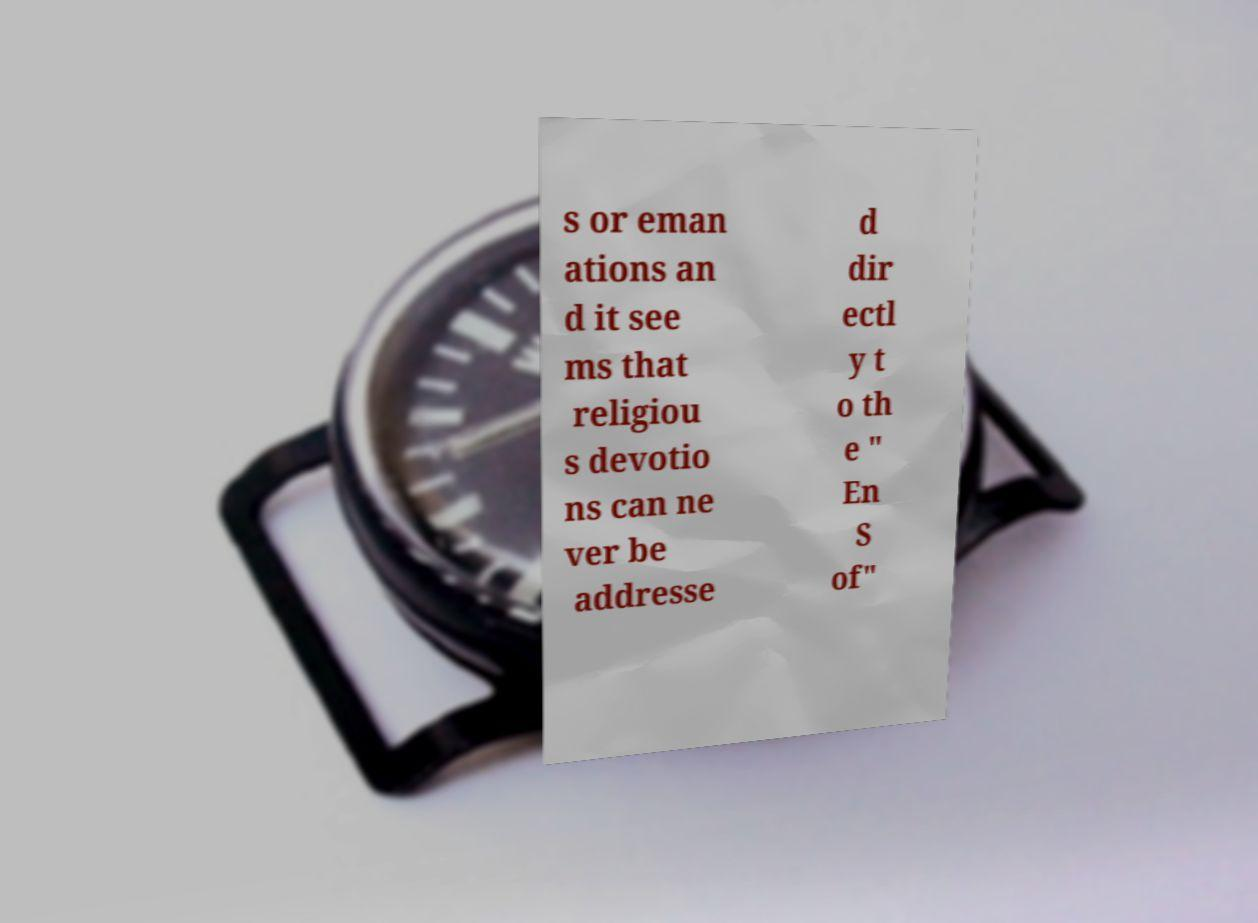Please identify and transcribe the text found in this image. s or eman ations an d it see ms that religiou s devotio ns can ne ver be addresse d dir ectl y t o th e " En S of" 